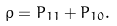<formula> <loc_0><loc_0><loc_500><loc_500>\rho = P _ { 1 1 } + P _ { 1 0 } .</formula> 